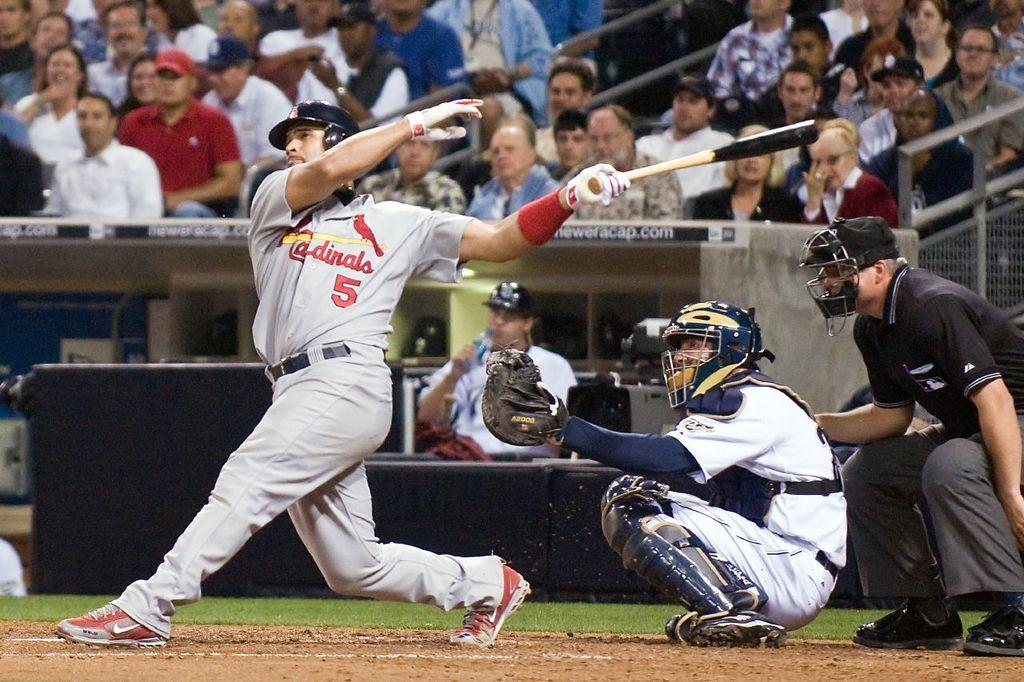<image>
Share a concise interpretation of the image provided. A baseball player for the Cardinals has swung his bat at the ball. 